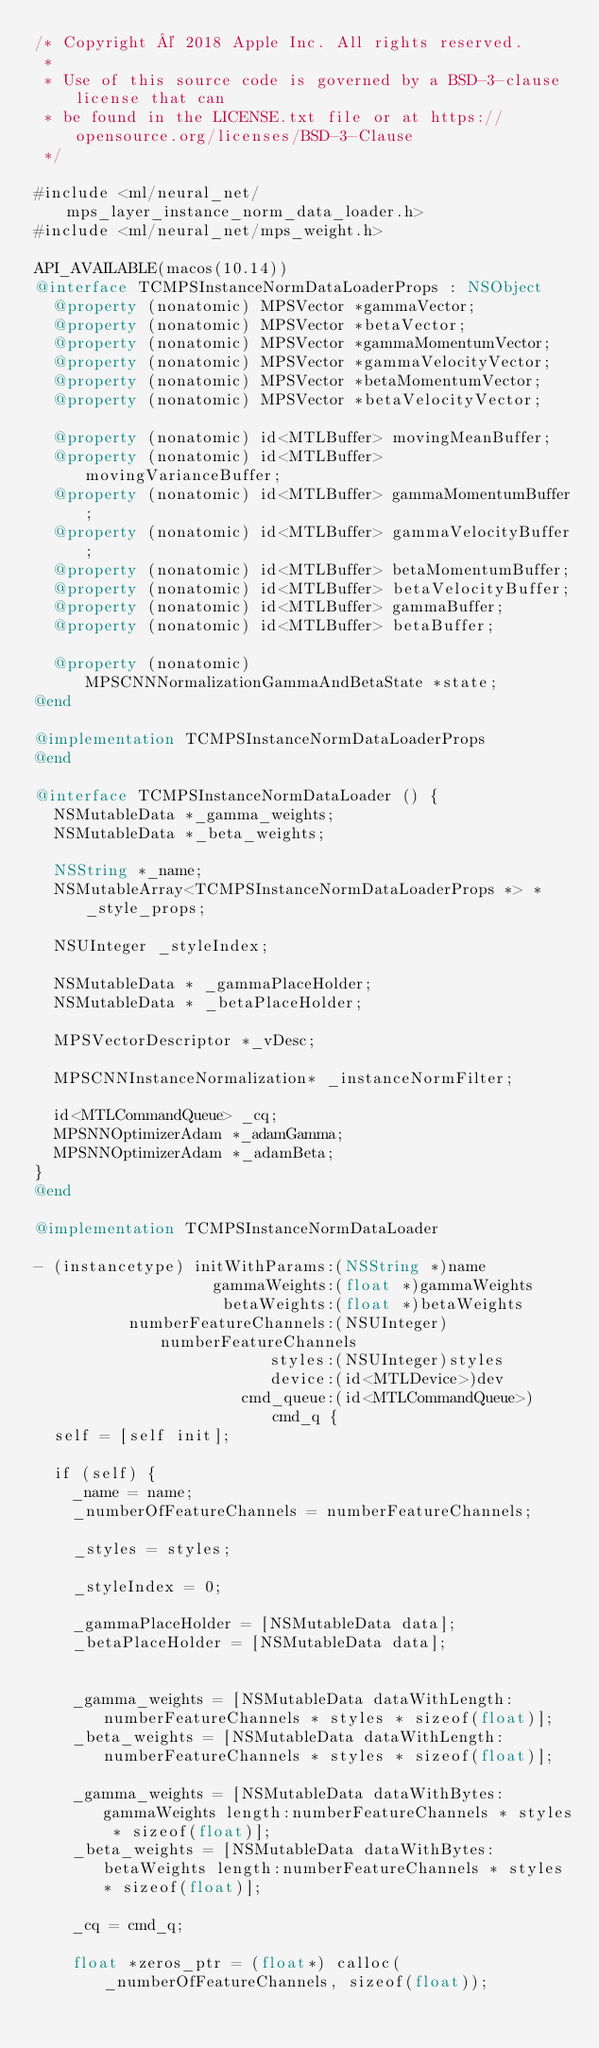Convert code to text. <code><loc_0><loc_0><loc_500><loc_500><_ObjectiveC_>/* Copyright © 2018 Apple Inc. All rights reserved.
 *
 * Use of this source code is governed by a BSD-3-clause license that can
 * be found in the LICENSE.txt file or at https://opensource.org/licenses/BSD-3-Clause
 */

#include <ml/neural_net/mps_layer_instance_norm_data_loader.h>
#include <ml/neural_net/mps_weight.h>

API_AVAILABLE(macos(10.14))
@interface TCMPSInstanceNormDataLoaderProps : NSObject
  @property (nonatomic) MPSVector *gammaVector;
  @property (nonatomic) MPSVector *betaVector;
  @property (nonatomic) MPSVector *gammaMomentumVector;
  @property (nonatomic) MPSVector *gammaVelocityVector;
  @property (nonatomic) MPSVector *betaMomentumVector;
  @property (nonatomic) MPSVector *betaVelocityVector;

  @property (nonatomic) id<MTLBuffer> movingMeanBuffer;
  @property (nonatomic) id<MTLBuffer> movingVarianceBuffer;
  @property (nonatomic) id<MTLBuffer> gammaMomentumBuffer;
  @property (nonatomic) id<MTLBuffer> gammaVelocityBuffer;
  @property (nonatomic) id<MTLBuffer> betaMomentumBuffer;
  @property (nonatomic) id<MTLBuffer> betaVelocityBuffer;
  @property (nonatomic) id<MTLBuffer> gammaBuffer;
  @property (nonatomic) id<MTLBuffer> betaBuffer;

  @property (nonatomic) MPSCNNNormalizationGammaAndBetaState *state;
@end

@implementation TCMPSInstanceNormDataLoaderProps 
@end

@interface TCMPSInstanceNormDataLoader () {
  NSMutableData *_gamma_weights;
  NSMutableData *_beta_weights;
  
  NSString *_name;
  NSMutableArray<TCMPSInstanceNormDataLoaderProps *> *_style_props;

  NSUInteger _styleIndex;

  NSMutableData * _gammaPlaceHolder;
  NSMutableData * _betaPlaceHolder;

  MPSVectorDescriptor *_vDesc;

  MPSCNNInstanceNormalization* _instanceNormFilter;

  id<MTLCommandQueue> _cq;
  MPSNNOptimizerAdam *_adamGamma;
  MPSNNOptimizerAdam *_adamBeta;
}
@end

@implementation TCMPSInstanceNormDataLoader

- (instancetype) initWithParams:(NSString *)name
                   gammaWeights:(float *)gammaWeights
                    betaWeights:(float *)betaWeights
          numberFeatureChannels:(NSUInteger)numberFeatureChannels
                         styles:(NSUInteger)styles
                         device:(id<MTLDevice>)dev 
                      cmd_queue:(id<MTLCommandQueue>) cmd_q {
  self = [self init];
    
  if (self) {
    _name = name;
    _numberOfFeatureChannels = numberFeatureChannels;

    _styles = styles;
    
    _styleIndex = 0;  
    
    _gammaPlaceHolder = [NSMutableData data];
    _betaPlaceHolder = [NSMutableData data];

    
    _gamma_weights = [NSMutableData dataWithLength:numberFeatureChannels * styles * sizeof(float)];
    _beta_weights = [NSMutableData dataWithLength:numberFeatureChannels * styles * sizeof(float)];

    _gamma_weights = [NSMutableData dataWithBytes:gammaWeights length:numberFeatureChannels * styles * sizeof(float)];
    _beta_weights = [NSMutableData dataWithBytes:betaWeights length:numberFeatureChannels * styles * sizeof(float)];

    _cq = cmd_q;

    float *zeros_ptr = (float*) calloc(_numberOfFeatureChannels, sizeof(float));</code> 